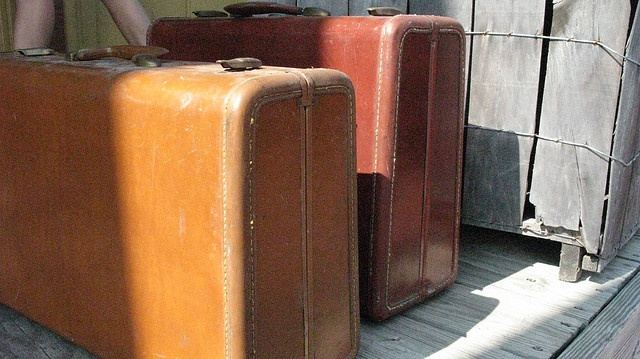Describe the objects in this image and their specific colors. I can see suitcase in darkgreen, maroon, orange, and gray tones and suitcase in darkgreen, maroon, black, gray, and salmon tones in this image. 